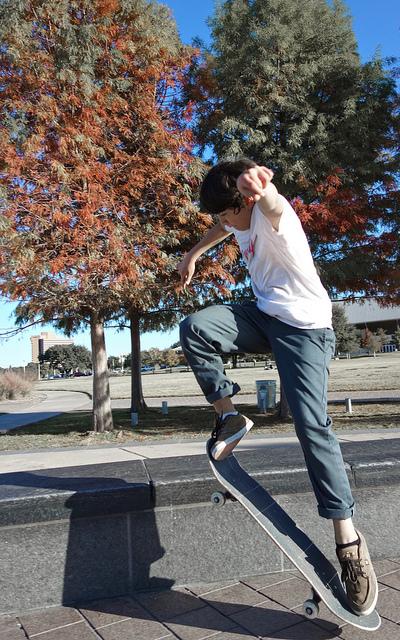Is the boy's shirt tucked in?
Quick response, please. No. Is the boy touching the ground?
Give a very brief answer. No. Does the boy have a destination he is traveling to?
Write a very short answer. No. 